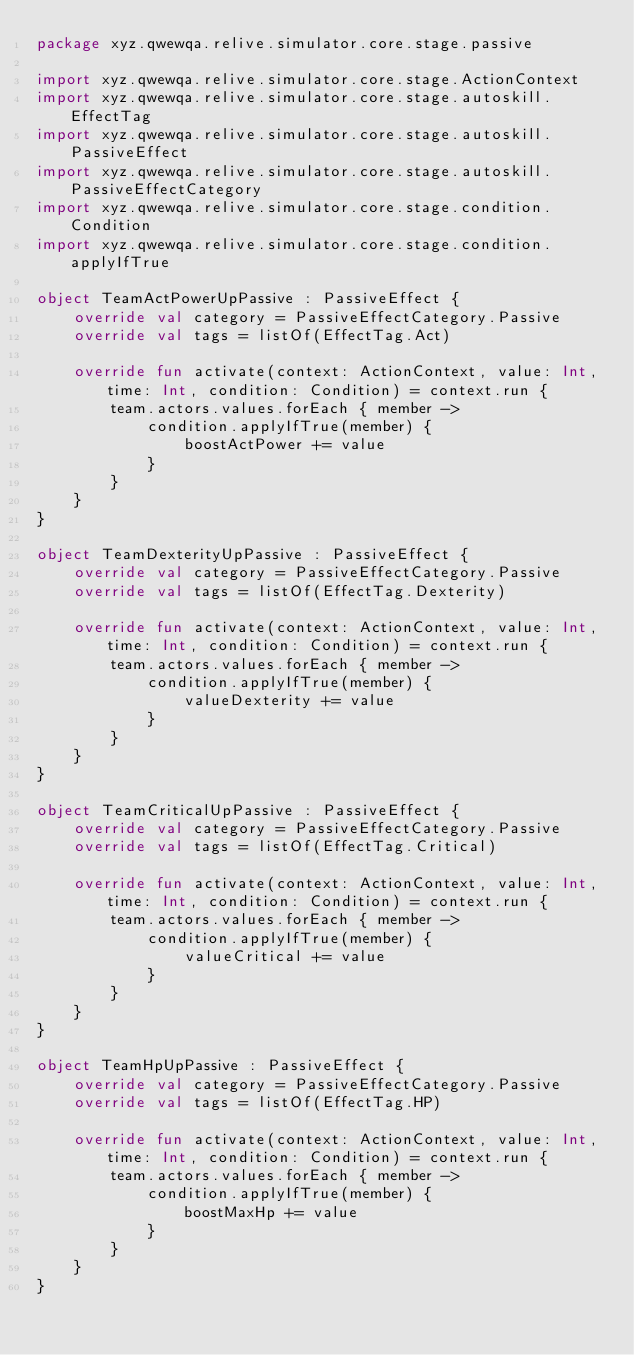<code> <loc_0><loc_0><loc_500><loc_500><_Kotlin_>package xyz.qwewqa.relive.simulator.core.stage.passive

import xyz.qwewqa.relive.simulator.core.stage.ActionContext
import xyz.qwewqa.relive.simulator.core.stage.autoskill.EffectTag
import xyz.qwewqa.relive.simulator.core.stage.autoskill.PassiveEffect
import xyz.qwewqa.relive.simulator.core.stage.autoskill.PassiveEffectCategory
import xyz.qwewqa.relive.simulator.core.stage.condition.Condition
import xyz.qwewqa.relive.simulator.core.stage.condition.applyIfTrue

object TeamActPowerUpPassive : PassiveEffect {
    override val category = PassiveEffectCategory.Passive
    override val tags = listOf(EffectTag.Act)

    override fun activate(context: ActionContext, value: Int, time: Int, condition: Condition) = context.run {
        team.actors.values.forEach { member ->
            condition.applyIfTrue(member) {
                boostActPower += value
            }
        }
    }
}

object TeamDexterityUpPassive : PassiveEffect {
    override val category = PassiveEffectCategory.Passive
    override val tags = listOf(EffectTag.Dexterity)

    override fun activate(context: ActionContext, value: Int, time: Int, condition: Condition) = context.run {
        team.actors.values.forEach { member ->
            condition.applyIfTrue(member) {
                valueDexterity += value
            }
        }
    }
}

object TeamCriticalUpPassive : PassiveEffect {
    override val category = PassiveEffectCategory.Passive
    override val tags = listOf(EffectTag.Critical)

    override fun activate(context: ActionContext, value: Int, time: Int, condition: Condition) = context.run {
        team.actors.values.forEach { member ->
            condition.applyIfTrue(member) {
                valueCritical += value
            }
        }
    }
}

object TeamHpUpPassive : PassiveEffect {
    override val category = PassiveEffectCategory.Passive
    override val tags = listOf(EffectTag.HP)

    override fun activate(context: ActionContext, value: Int, time: Int, condition: Condition) = context.run {
        team.actors.values.forEach { member ->
            condition.applyIfTrue(member) {
                boostMaxHp += value
            }
        }
    }
}
</code> 